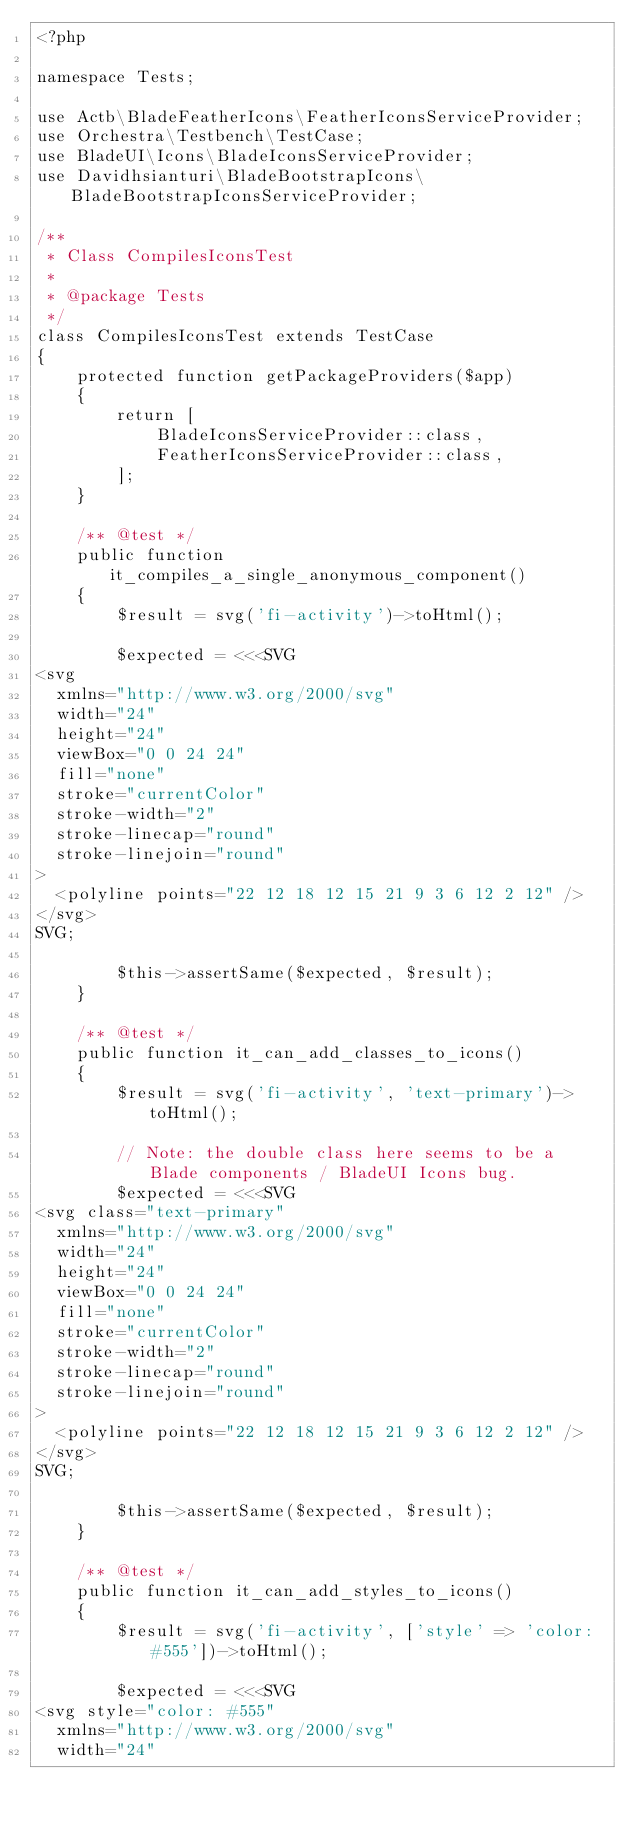Convert code to text. <code><loc_0><loc_0><loc_500><loc_500><_PHP_><?php

namespace Tests;

use Actb\BladeFeatherIcons\FeatherIconsServiceProvider;
use Orchestra\Testbench\TestCase;
use BladeUI\Icons\BladeIconsServiceProvider;
use Davidhsianturi\BladeBootstrapIcons\BladeBootstrapIconsServiceProvider;

/**
 * Class CompilesIconsTest
 *
 * @package Tests
 */
class CompilesIconsTest extends TestCase
{
    protected function getPackageProviders($app)
    {
        return [
            BladeIconsServiceProvider::class,
            FeatherIconsServiceProvider::class,
        ];
    }

    /** @test */
    public function it_compiles_a_single_anonymous_component()
    {
        $result = svg('fi-activity')->toHtml();

        $expected = <<<SVG
<svg
  xmlns="http://www.w3.org/2000/svg"
  width="24"
  height="24"
  viewBox="0 0 24 24"
  fill="none"
  stroke="currentColor"
  stroke-width="2"
  stroke-linecap="round"
  stroke-linejoin="round"
>
  <polyline points="22 12 18 12 15 21 9 3 6 12 2 12" />
</svg>
SVG;

        $this->assertSame($expected, $result);
    }

    /** @test */
    public function it_can_add_classes_to_icons()
    {
        $result = svg('fi-activity', 'text-primary')->toHtml();

        // Note: the double class here seems to be a Blade components / BladeUI Icons bug.
        $expected = <<<SVG
<svg class="text-primary"
  xmlns="http://www.w3.org/2000/svg"
  width="24"
  height="24"
  viewBox="0 0 24 24"
  fill="none"
  stroke="currentColor"
  stroke-width="2"
  stroke-linecap="round"
  stroke-linejoin="round"
>
  <polyline points="22 12 18 12 15 21 9 3 6 12 2 12" />
</svg>
SVG;

        $this->assertSame($expected, $result);
    }

    /** @test */
    public function it_can_add_styles_to_icons()
    {
        $result = svg('fi-activity', ['style' => 'color: #555'])->toHtml();

        $expected = <<<SVG
<svg style="color: #555"
  xmlns="http://www.w3.org/2000/svg"
  width="24"</code> 